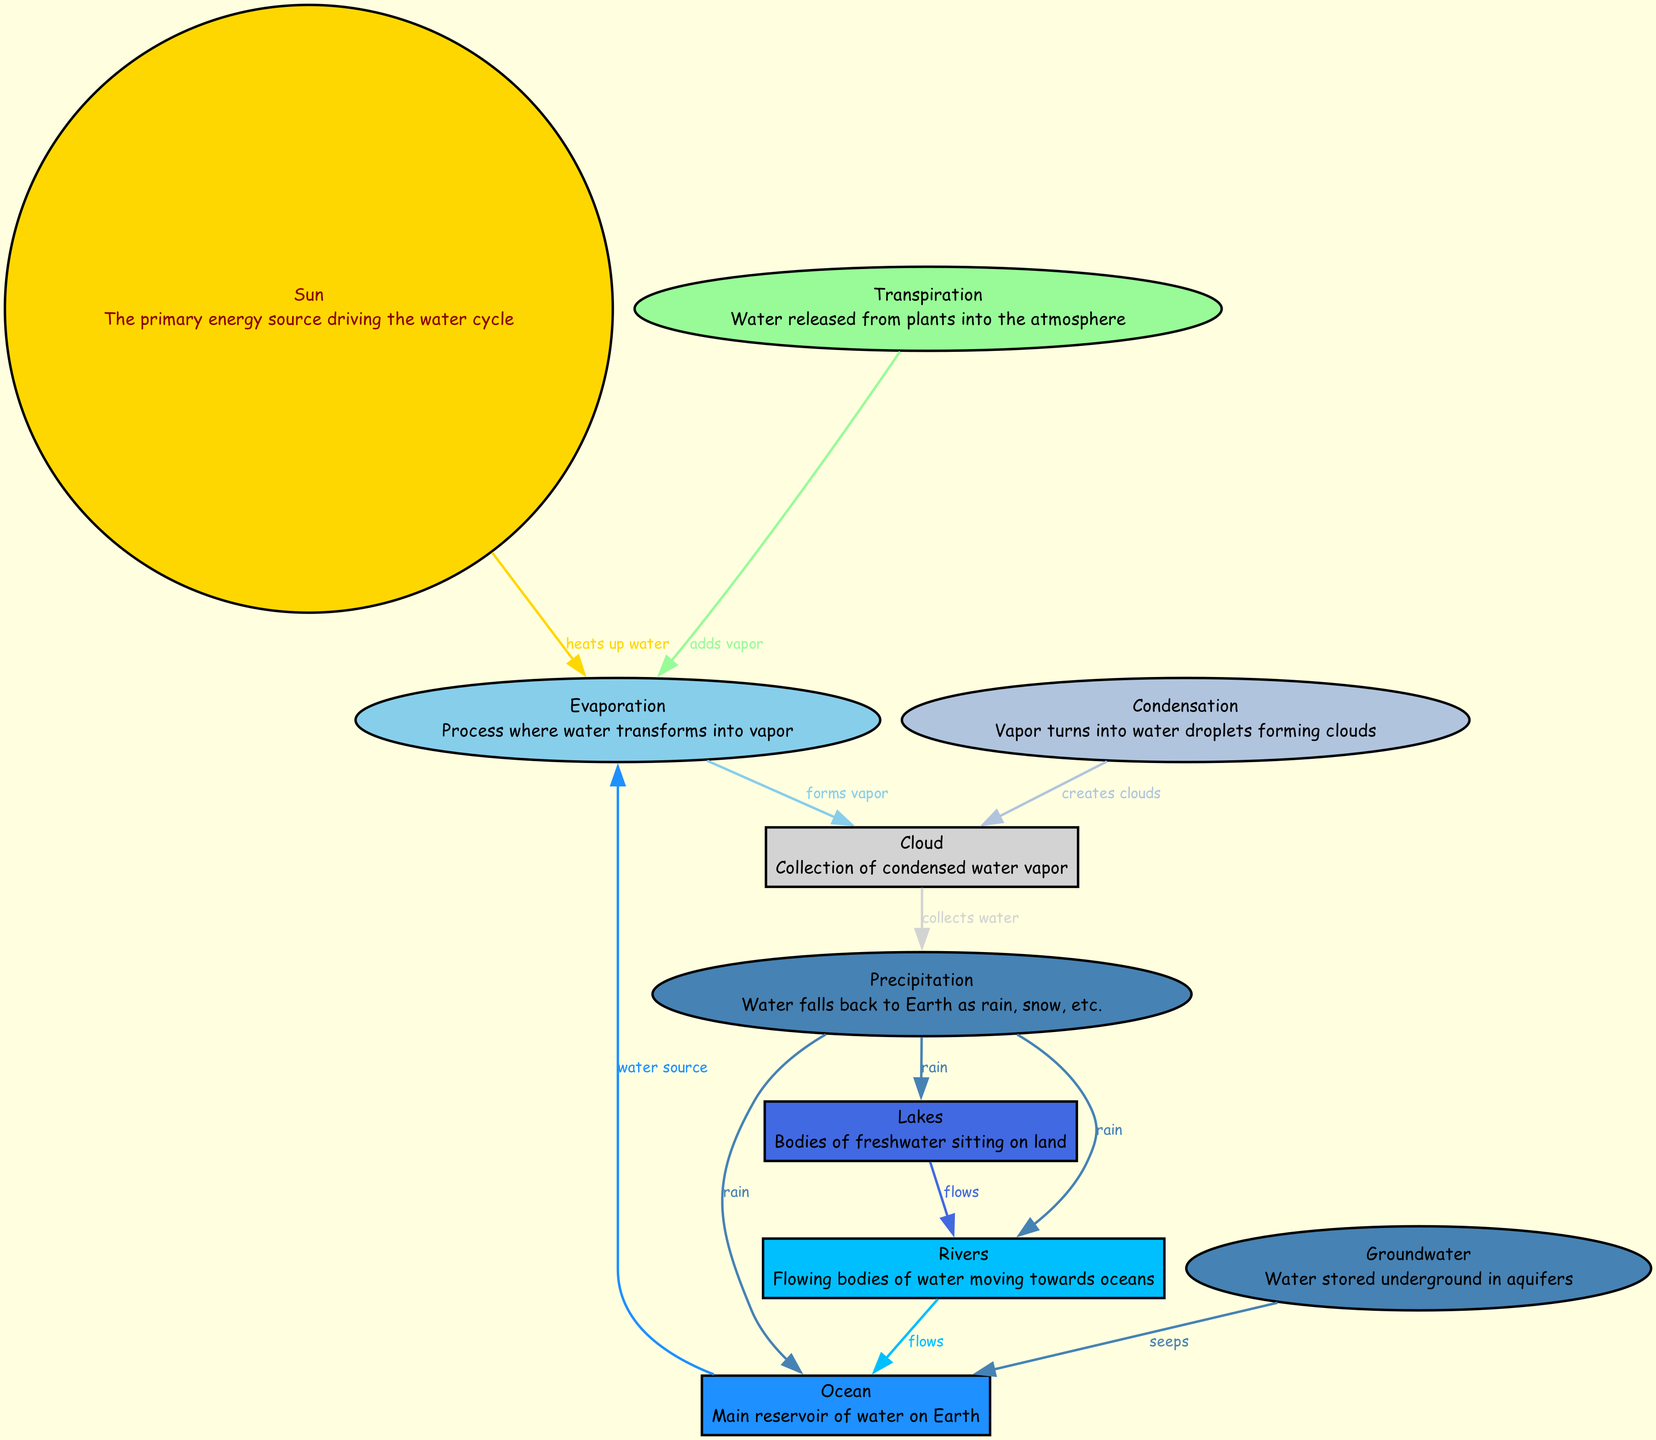What is the main source of energy in the water cycle? The diagram identifies the "Sun" as the primary energy source driving the water cycle. This is depicted in the node labeled "Sun".
Answer: Sun How many stages are illustrated in the diagram? The diagram includes several nodes representing different stages: Evaporation, Condensation, Cloud, Precipitation, and more. Counting these stages, we find there are a total of 7 distinct processes related to the water cycle represented in the diagram.
Answer: 7 What process transforms water into vapor? In the diagram, the node labeled "Evaporation" directly describes the process where water transforms into vapor. Thus, Evaporation is the stage where this transformation occurs.
Answer: Evaporation From which two sources does water primarily evaporate? The edges in the diagram show connections from both the "Ocean" (identified as the main reservoir of water) and "Transpiration" (which adds vapor) leading to "Evaporation". These connections indicate that water primarily evaporates from the Ocean and through Transpiration by plants.
Answer: Ocean and Transpiration What does the "Cloud" node represent? The "Cloud" node in the diagram is described as a collection of condensed water vapor. This represents an important stage where vapor has condensed to form visible clouds.
Answer: Collection of condensed water vapor What happens to water after it precipitates? The diagram illustrates that after "Precipitation", the water can fall to multiple destinations: it can flow into "Lakes", "Rivers", or return into the "Ocean". Thus, precipitation leads to water being distributed into these three locations.
Answer: Lakes, Rivers, and Ocean What process follows condensation in the cycle? Looking at the diagram's progression, after "Evaporation", water vapor undergoes "Condensation", leading to the "Cloud" phase, hence the process that directly follows condensation is cloud formation.
Answer: Cloud How does groundwater interact with the ocean according to the diagram? The diagram shows that "Groundwater" seeps into the "Ocean", indicating an interaction where underground water contributes to the quantity of water in the ocean. This relationship illustrates how groundwater feeds into larger bodies of water.
Answer: Seeps 